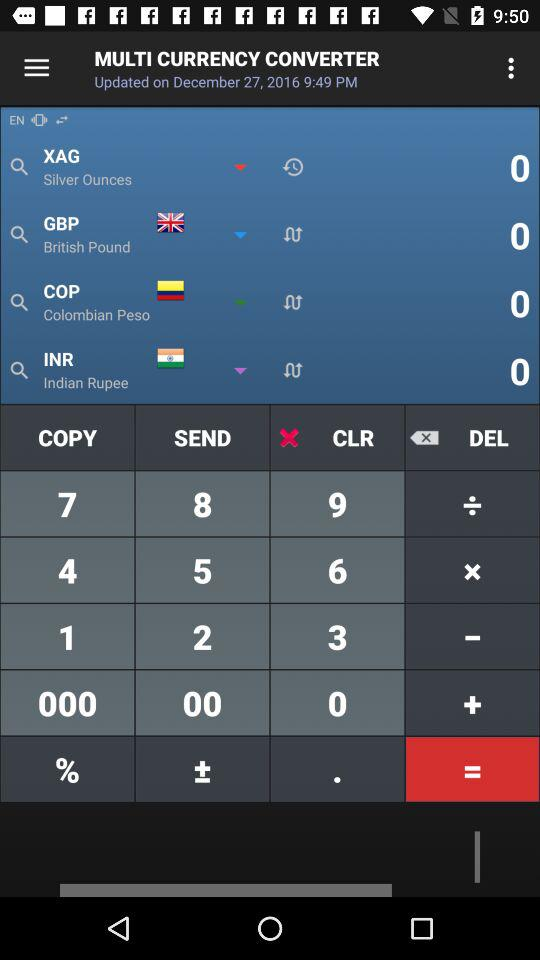What is the currency of India? The currency of India is the Indian rupee. 